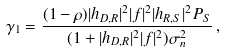<formula> <loc_0><loc_0><loc_500><loc_500>\gamma _ { 1 } = \frac { ( 1 - \rho ) | h _ { D , R } | ^ { 2 } | f | ^ { 2 } | h _ { R , S } | ^ { 2 } P _ { S } } { ( 1 + | h _ { D , R } | ^ { 2 } | f | ^ { 2 } ) \sigma _ { n } ^ { 2 } } \, ,</formula> 